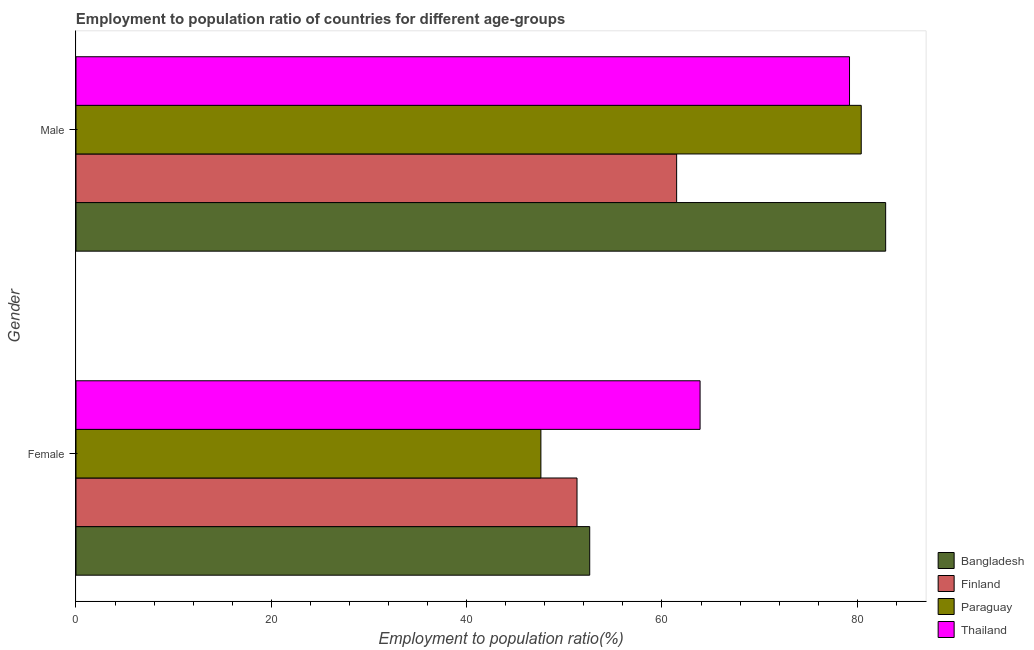How many different coloured bars are there?
Make the answer very short. 4. How many groups of bars are there?
Make the answer very short. 2. Are the number of bars per tick equal to the number of legend labels?
Your answer should be compact. Yes. How many bars are there on the 2nd tick from the top?
Your answer should be very brief. 4. What is the employment to population ratio(male) in Thailand?
Your answer should be compact. 79.2. Across all countries, what is the maximum employment to population ratio(female)?
Make the answer very short. 63.9. Across all countries, what is the minimum employment to population ratio(male)?
Keep it short and to the point. 61.5. In which country was the employment to population ratio(female) minimum?
Ensure brevity in your answer.  Paraguay. What is the total employment to population ratio(female) in the graph?
Your answer should be very brief. 215.4. What is the difference between the employment to population ratio(male) in Paraguay and the employment to population ratio(female) in Thailand?
Your response must be concise. 16.5. What is the average employment to population ratio(male) per country?
Provide a short and direct response. 76. What is the difference between the employment to population ratio(female) and employment to population ratio(male) in Bangladesh?
Provide a succinct answer. -30.3. What is the ratio of the employment to population ratio(male) in Thailand to that in Finland?
Make the answer very short. 1.29. Is the employment to population ratio(male) in Paraguay less than that in Thailand?
Make the answer very short. No. In how many countries, is the employment to population ratio(female) greater than the average employment to population ratio(female) taken over all countries?
Keep it short and to the point. 1. What does the 2nd bar from the top in Male represents?
Your answer should be very brief. Paraguay. What does the 1st bar from the bottom in Male represents?
Offer a terse response. Bangladesh. What is the difference between two consecutive major ticks on the X-axis?
Your response must be concise. 20. Does the graph contain any zero values?
Your response must be concise. No. Does the graph contain grids?
Provide a short and direct response. No. How many legend labels are there?
Keep it short and to the point. 4. How are the legend labels stacked?
Keep it short and to the point. Vertical. What is the title of the graph?
Your answer should be compact. Employment to population ratio of countries for different age-groups. Does "New Caledonia" appear as one of the legend labels in the graph?
Your answer should be very brief. No. What is the label or title of the X-axis?
Provide a short and direct response. Employment to population ratio(%). What is the label or title of the Y-axis?
Make the answer very short. Gender. What is the Employment to population ratio(%) of Bangladesh in Female?
Ensure brevity in your answer.  52.6. What is the Employment to population ratio(%) in Finland in Female?
Your answer should be compact. 51.3. What is the Employment to population ratio(%) in Paraguay in Female?
Keep it short and to the point. 47.6. What is the Employment to population ratio(%) of Thailand in Female?
Your response must be concise. 63.9. What is the Employment to population ratio(%) in Bangladesh in Male?
Keep it short and to the point. 82.9. What is the Employment to population ratio(%) in Finland in Male?
Ensure brevity in your answer.  61.5. What is the Employment to population ratio(%) of Paraguay in Male?
Offer a very short reply. 80.4. What is the Employment to population ratio(%) of Thailand in Male?
Keep it short and to the point. 79.2. Across all Gender, what is the maximum Employment to population ratio(%) in Bangladesh?
Make the answer very short. 82.9. Across all Gender, what is the maximum Employment to population ratio(%) in Finland?
Make the answer very short. 61.5. Across all Gender, what is the maximum Employment to population ratio(%) in Paraguay?
Provide a succinct answer. 80.4. Across all Gender, what is the maximum Employment to population ratio(%) in Thailand?
Your response must be concise. 79.2. Across all Gender, what is the minimum Employment to population ratio(%) in Bangladesh?
Your answer should be very brief. 52.6. Across all Gender, what is the minimum Employment to population ratio(%) in Finland?
Your answer should be compact. 51.3. Across all Gender, what is the minimum Employment to population ratio(%) in Paraguay?
Your answer should be very brief. 47.6. Across all Gender, what is the minimum Employment to population ratio(%) of Thailand?
Your answer should be very brief. 63.9. What is the total Employment to population ratio(%) in Bangladesh in the graph?
Make the answer very short. 135.5. What is the total Employment to population ratio(%) in Finland in the graph?
Make the answer very short. 112.8. What is the total Employment to population ratio(%) of Paraguay in the graph?
Keep it short and to the point. 128. What is the total Employment to population ratio(%) in Thailand in the graph?
Your answer should be very brief. 143.1. What is the difference between the Employment to population ratio(%) of Bangladesh in Female and that in Male?
Give a very brief answer. -30.3. What is the difference between the Employment to population ratio(%) in Paraguay in Female and that in Male?
Make the answer very short. -32.8. What is the difference between the Employment to population ratio(%) of Thailand in Female and that in Male?
Your answer should be compact. -15.3. What is the difference between the Employment to population ratio(%) in Bangladesh in Female and the Employment to population ratio(%) in Paraguay in Male?
Your answer should be compact. -27.8. What is the difference between the Employment to population ratio(%) of Bangladesh in Female and the Employment to population ratio(%) of Thailand in Male?
Ensure brevity in your answer.  -26.6. What is the difference between the Employment to population ratio(%) in Finland in Female and the Employment to population ratio(%) in Paraguay in Male?
Provide a short and direct response. -29.1. What is the difference between the Employment to population ratio(%) of Finland in Female and the Employment to population ratio(%) of Thailand in Male?
Make the answer very short. -27.9. What is the difference between the Employment to population ratio(%) of Paraguay in Female and the Employment to population ratio(%) of Thailand in Male?
Provide a succinct answer. -31.6. What is the average Employment to population ratio(%) of Bangladesh per Gender?
Your response must be concise. 67.75. What is the average Employment to population ratio(%) in Finland per Gender?
Ensure brevity in your answer.  56.4. What is the average Employment to population ratio(%) in Thailand per Gender?
Your answer should be compact. 71.55. What is the difference between the Employment to population ratio(%) in Bangladesh and Employment to population ratio(%) in Paraguay in Female?
Keep it short and to the point. 5. What is the difference between the Employment to population ratio(%) of Paraguay and Employment to population ratio(%) of Thailand in Female?
Offer a terse response. -16.3. What is the difference between the Employment to population ratio(%) of Bangladesh and Employment to population ratio(%) of Finland in Male?
Offer a terse response. 21.4. What is the difference between the Employment to population ratio(%) in Bangladesh and Employment to population ratio(%) in Paraguay in Male?
Your response must be concise. 2.5. What is the difference between the Employment to population ratio(%) in Bangladesh and Employment to population ratio(%) in Thailand in Male?
Ensure brevity in your answer.  3.7. What is the difference between the Employment to population ratio(%) in Finland and Employment to population ratio(%) in Paraguay in Male?
Provide a short and direct response. -18.9. What is the difference between the Employment to population ratio(%) in Finland and Employment to population ratio(%) in Thailand in Male?
Give a very brief answer. -17.7. What is the ratio of the Employment to population ratio(%) in Bangladesh in Female to that in Male?
Offer a very short reply. 0.63. What is the ratio of the Employment to population ratio(%) in Finland in Female to that in Male?
Keep it short and to the point. 0.83. What is the ratio of the Employment to population ratio(%) of Paraguay in Female to that in Male?
Your response must be concise. 0.59. What is the ratio of the Employment to population ratio(%) of Thailand in Female to that in Male?
Make the answer very short. 0.81. What is the difference between the highest and the second highest Employment to population ratio(%) of Bangladesh?
Provide a short and direct response. 30.3. What is the difference between the highest and the second highest Employment to population ratio(%) of Paraguay?
Your answer should be compact. 32.8. What is the difference between the highest and the second highest Employment to population ratio(%) in Thailand?
Make the answer very short. 15.3. What is the difference between the highest and the lowest Employment to population ratio(%) in Bangladesh?
Give a very brief answer. 30.3. What is the difference between the highest and the lowest Employment to population ratio(%) of Finland?
Provide a succinct answer. 10.2. What is the difference between the highest and the lowest Employment to population ratio(%) in Paraguay?
Ensure brevity in your answer.  32.8. 